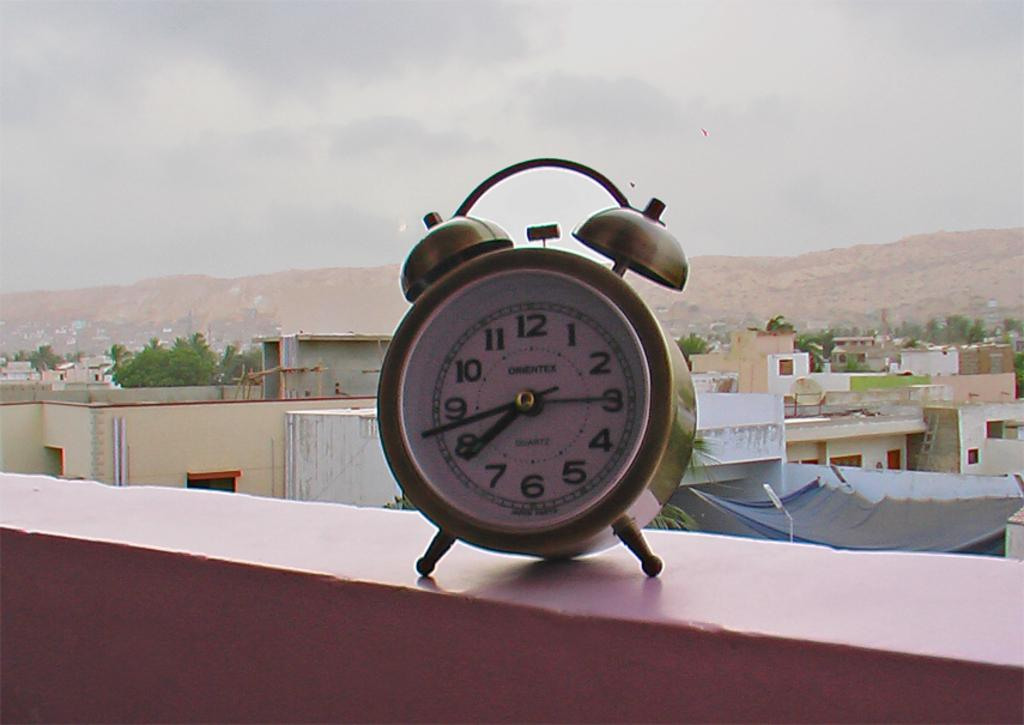Provide a one-sentence caption for the provided image. A clock with the hands showing the time of 7:43. 